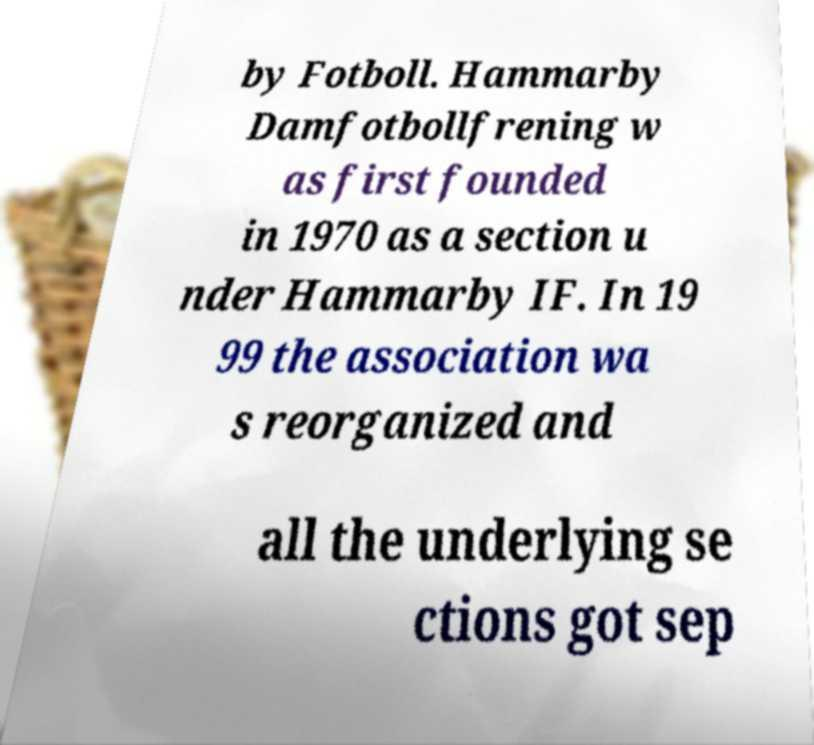There's text embedded in this image that I need extracted. Can you transcribe it verbatim? by Fotboll. Hammarby Damfotbollfrening w as first founded in 1970 as a section u nder Hammarby IF. In 19 99 the association wa s reorganized and all the underlying se ctions got sep 